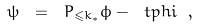Convert formula to latex. <formula><loc_0><loc_0><loc_500><loc_500>\psi \ = \ P _ { \leqslant k _ { * } } \phi - \ t p h i \ ,</formula> 